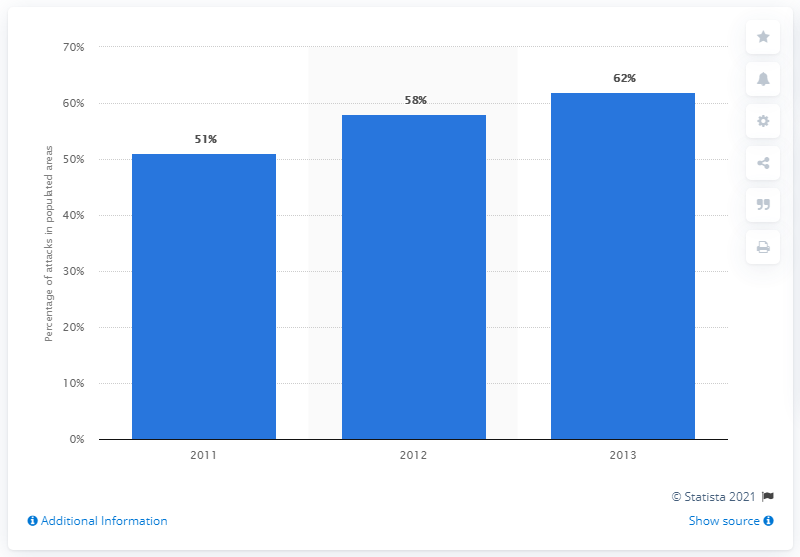Point out several critical features in this image. In 2013, the percentage of attacks reached its peak. The difference between the highest and lowest bar in the graph is 11. 